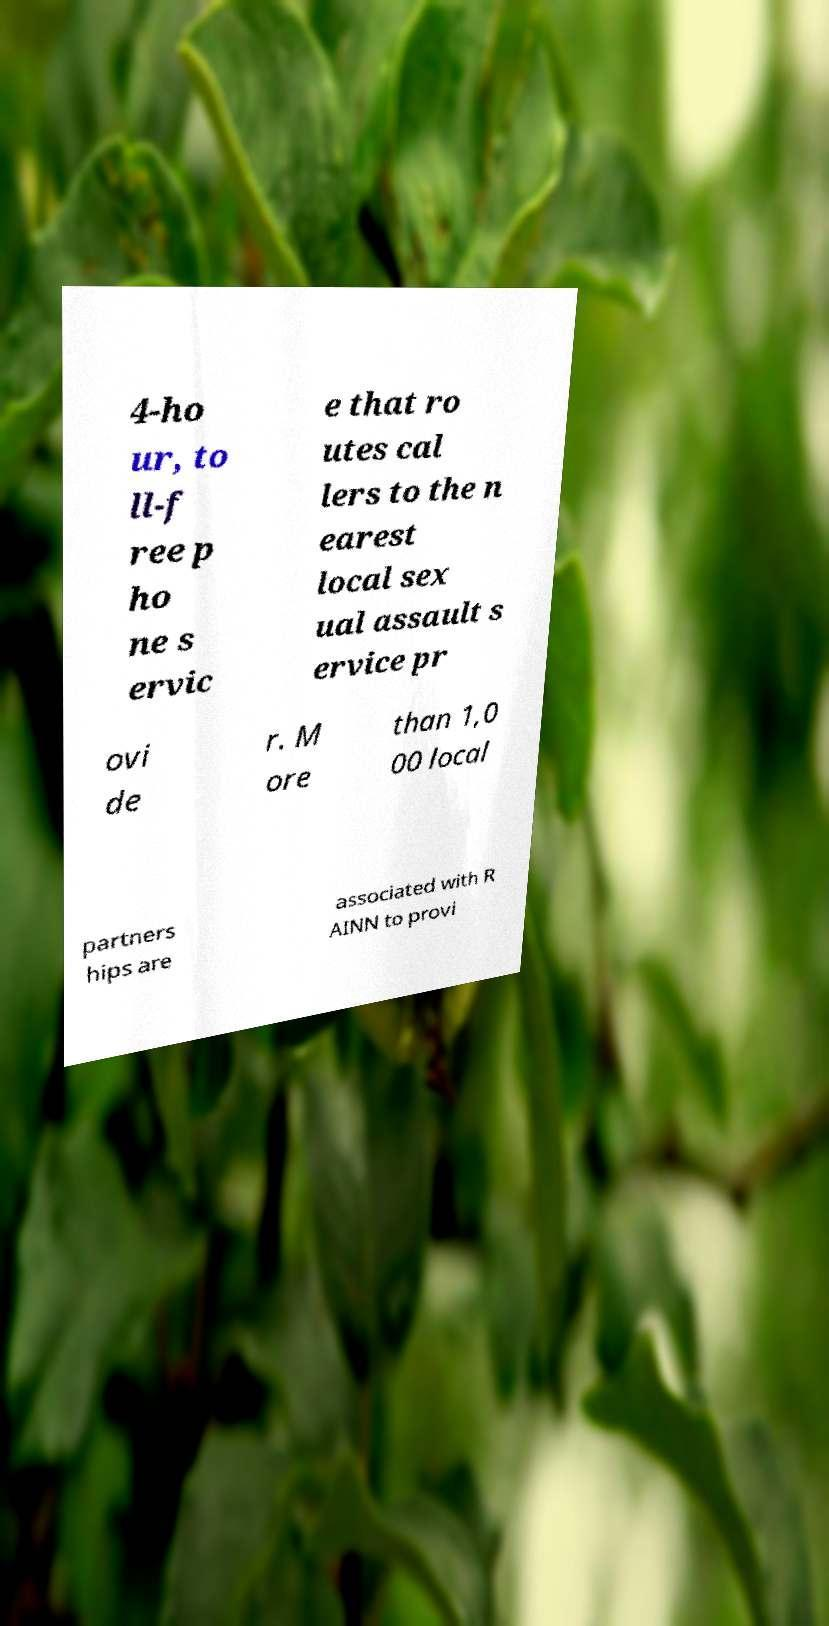Could you assist in decoding the text presented in this image and type it out clearly? 4-ho ur, to ll-f ree p ho ne s ervic e that ro utes cal lers to the n earest local sex ual assault s ervice pr ovi de r. M ore than 1,0 00 local partners hips are associated with R AINN to provi 